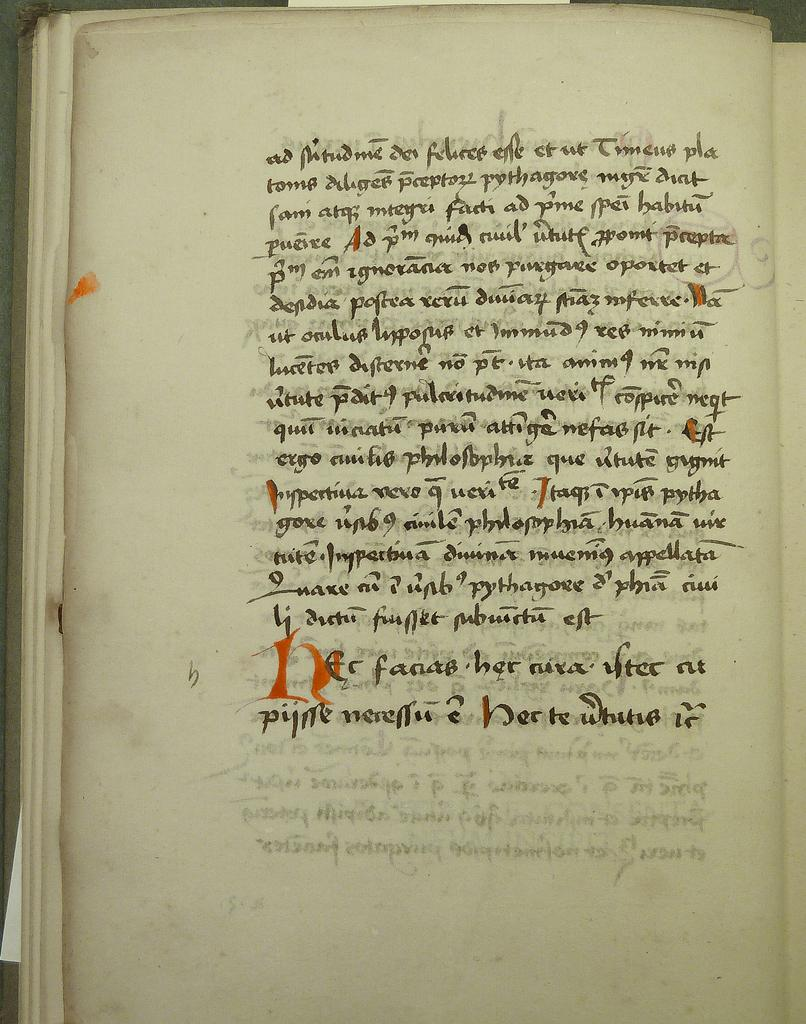What is the main subject of the image? The main subject of the image is a page. What can be found on the page? The page contains some text. Where is the ball located in the image? There is no ball present in the image. What type of nest can be seen on the page? There is no nest present on the page; it contains text. What is the bottle used for in the image? There is no bottle present in the image. 